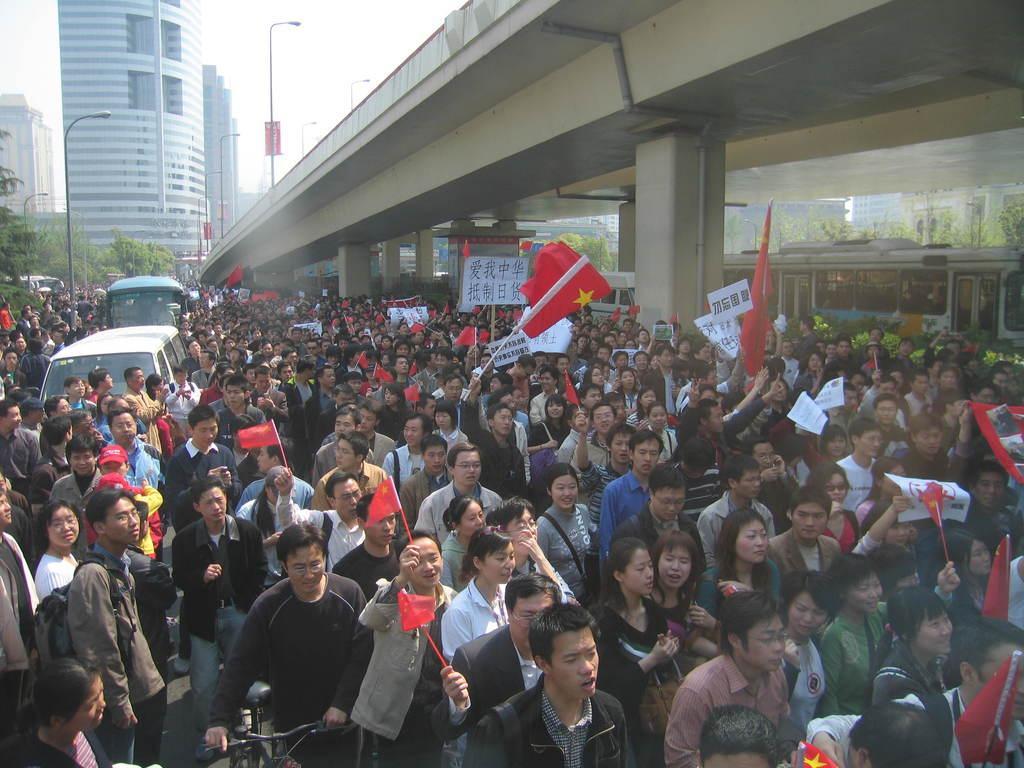Please provide a concise description of this image. In this image I can see the group of people with different color dresses. I can see few people are holding the flags. To the side I can see the vehicles and light poles. In the background I can see the bridge, buildings and the sky. 